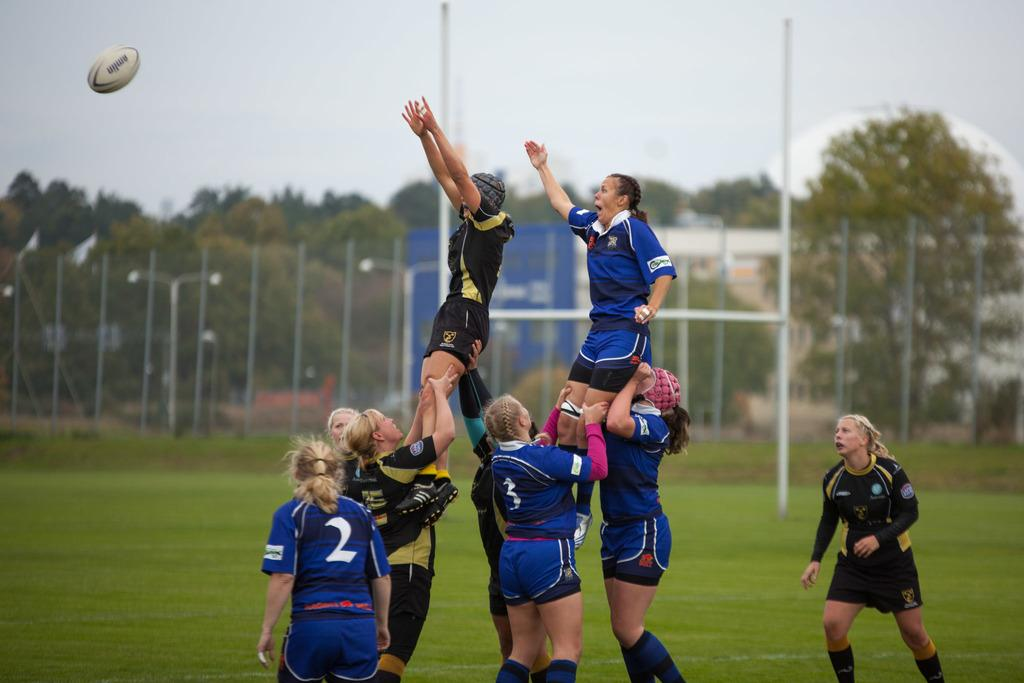<image>
Give a short and clear explanation of the subsequent image. Group of female rugby players with number two running towards them 